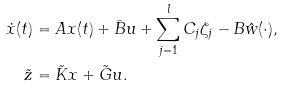Convert formula to latex. <formula><loc_0><loc_0><loc_500><loc_500>\dot { x } ( t ) & = A x ( t ) + \bar { B } u + \sum ^ { l } _ { j = 1 } C _ { j } \zeta _ { j } - B \hat { w } ( \cdot ) , \\ \tilde { z } & = \tilde { K } x + \tilde { G } u .</formula> 